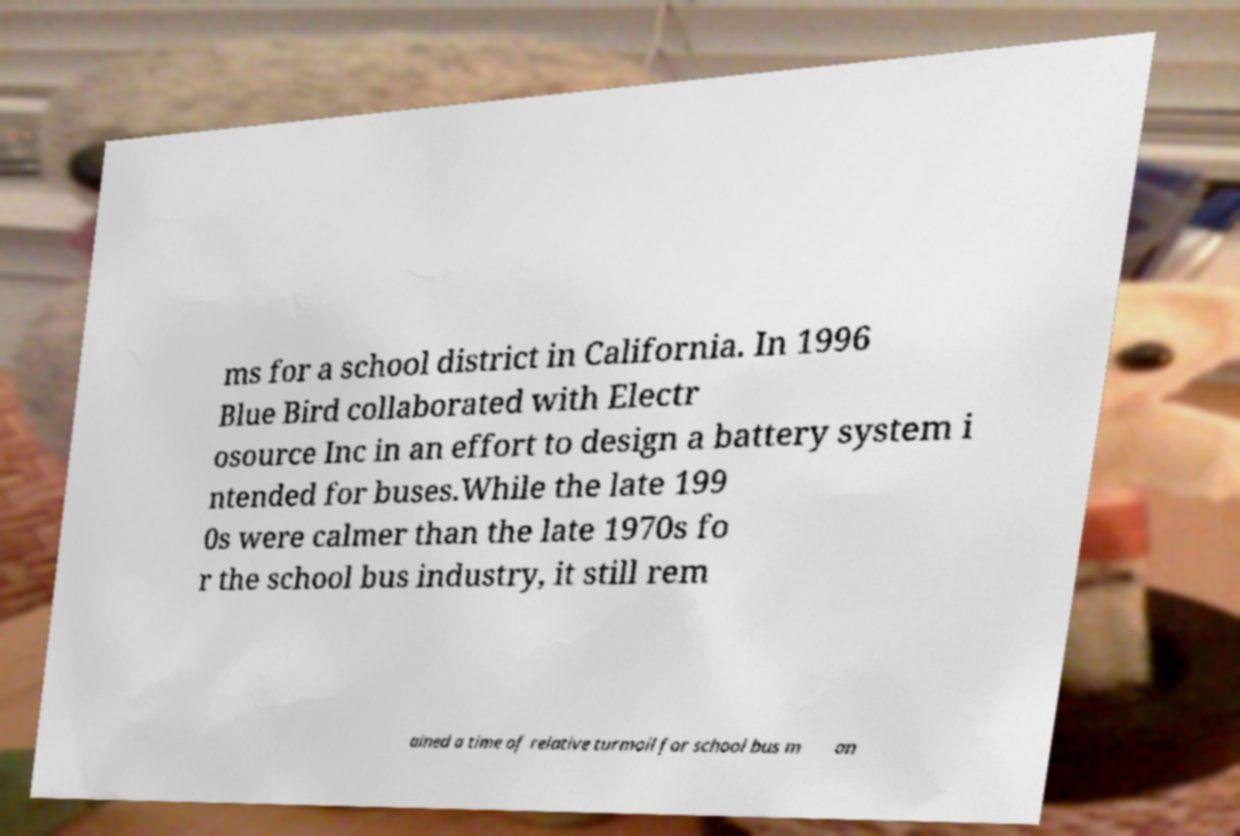Could you assist in decoding the text presented in this image and type it out clearly? ms for a school district in California. In 1996 Blue Bird collaborated with Electr osource Inc in an effort to design a battery system i ntended for buses.While the late 199 0s were calmer than the late 1970s fo r the school bus industry, it still rem ained a time of relative turmoil for school bus m an 